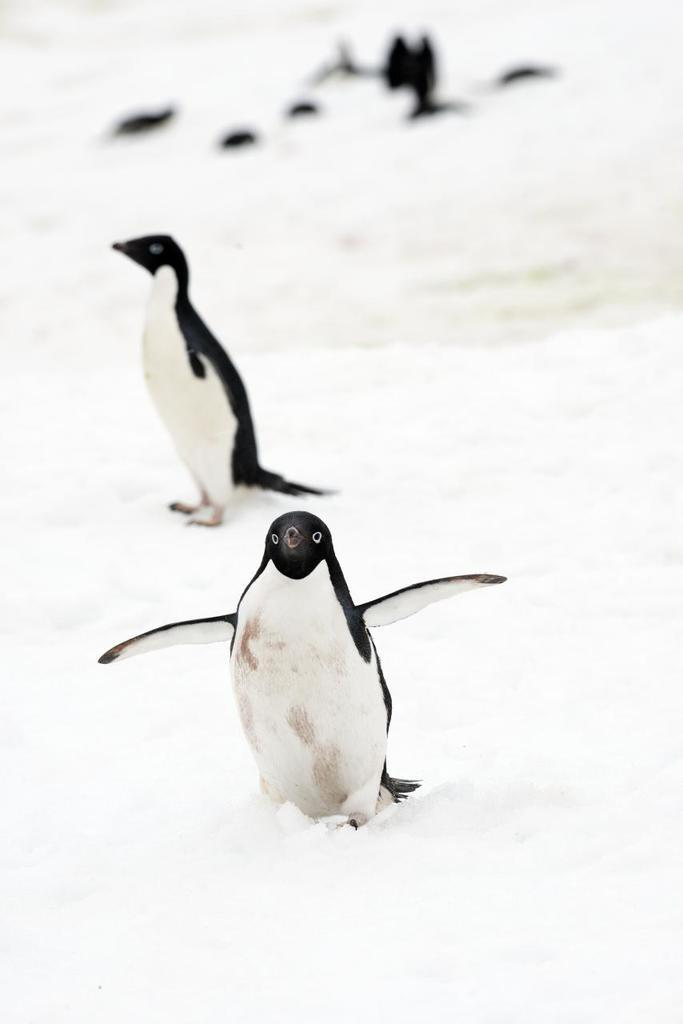What type of animals are in the image? There are penguins in the image. What is the environment in which the penguins are located? The penguins are on the snow. What type of creature is the woman cooking in the image? There is no woman or cooking activity present in the image; it features penguins on the snow. 